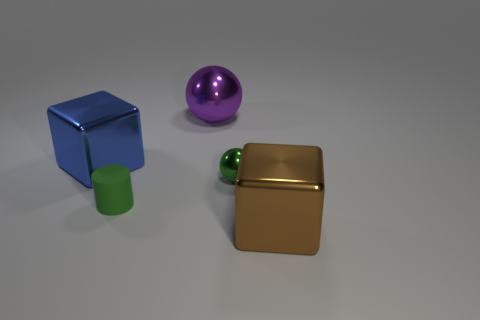What shape is the other object that is the same color as the tiny rubber thing?
Offer a very short reply. Sphere. There is a tiny green matte object; is its shape the same as the small object behind the green rubber thing?
Give a very brief answer. No. What number of small objects are either purple shiny cylinders or cylinders?
Keep it short and to the point. 1. Is there a purple shiny cube of the same size as the brown cube?
Your answer should be very brief. No. There is a cube that is on the left side of the metallic thing that is in front of the small thing that is to the right of the tiny green matte cylinder; what is its color?
Your answer should be very brief. Blue. Are the large purple thing and the big block behind the large brown metal thing made of the same material?
Offer a very short reply. Yes. The green metallic thing that is the same shape as the large purple thing is what size?
Keep it short and to the point. Small. Is the number of objects behind the large ball the same as the number of large cubes that are in front of the tiny metal sphere?
Make the answer very short. No. What number of other objects are the same material as the large purple sphere?
Keep it short and to the point. 3. Are there the same number of metallic blocks that are to the right of the purple thing and big shiny things?
Give a very brief answer. No. 